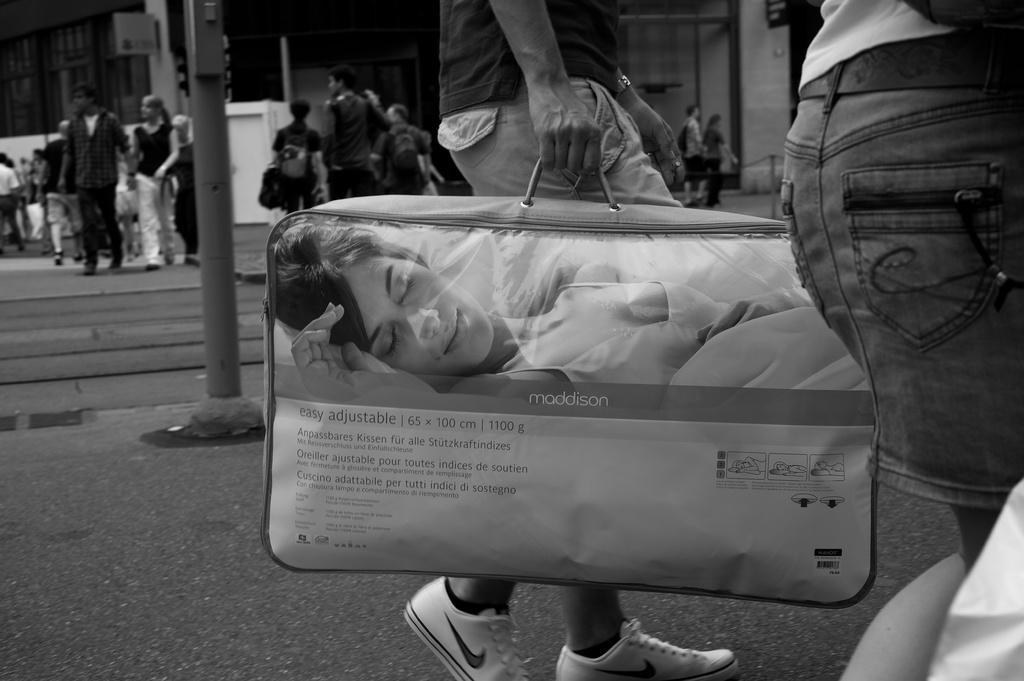In one or two sentences, can you explain what this image depicts? In this black and white image, we can see persons wearing clothes. There is a person in the middle of the image holding a bag with his hand. There is a pole on the left side of the image. 